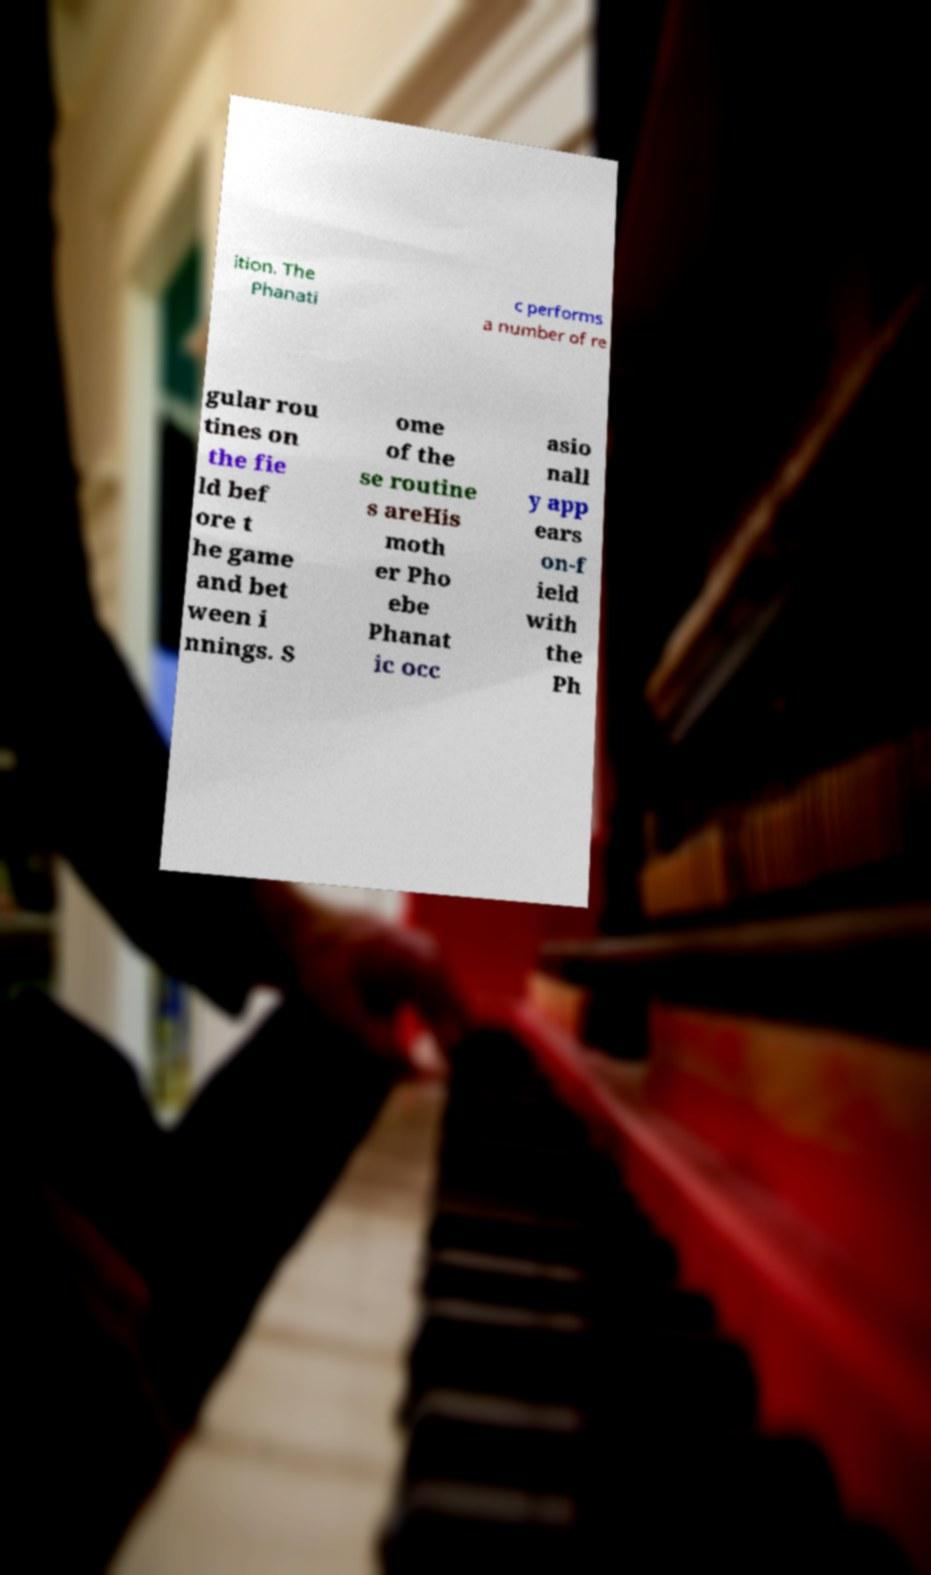Please identify and transcribe the text found in this image. ition. The Phanati c performs a number of re gular rou tines on the fie ld bef ore t he game and bet ween i nnings. S ome of the se routine s areHis moth er Pho ebe Phanat ic occ asio nall y app ears on-f ield with the Ph 